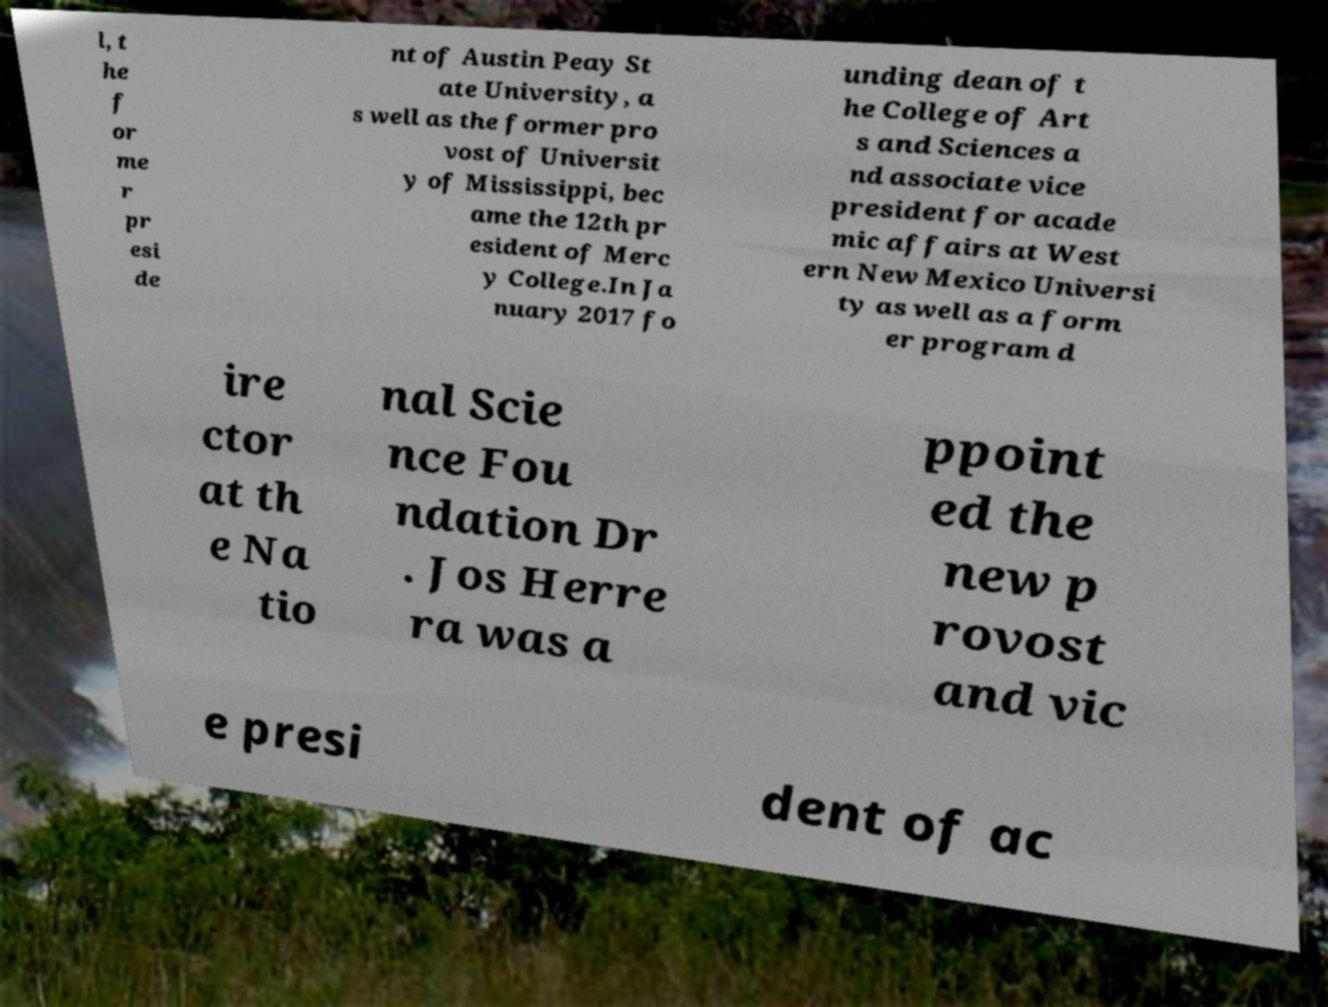Please identify and transcribe the text found in this image. l, t he f or me r pr esi de nt of Austin Peay St ate University, a s well as the former pro vost of Universit y of Mississippi, bec ame the 12th pr esident of Merc y College.In Ja nuary 2017 fo unding dean of t he College of Art s and Sciences a nd associate vice president for acade mic affairs at West ern New Mexico Universi ty as well as a form er program d ire ctor at th e Na tio nal Scie nce Fou ndation Dr . Jos Herre ra was a ppoint ed the new p rovost and vic e presi dent of ac 